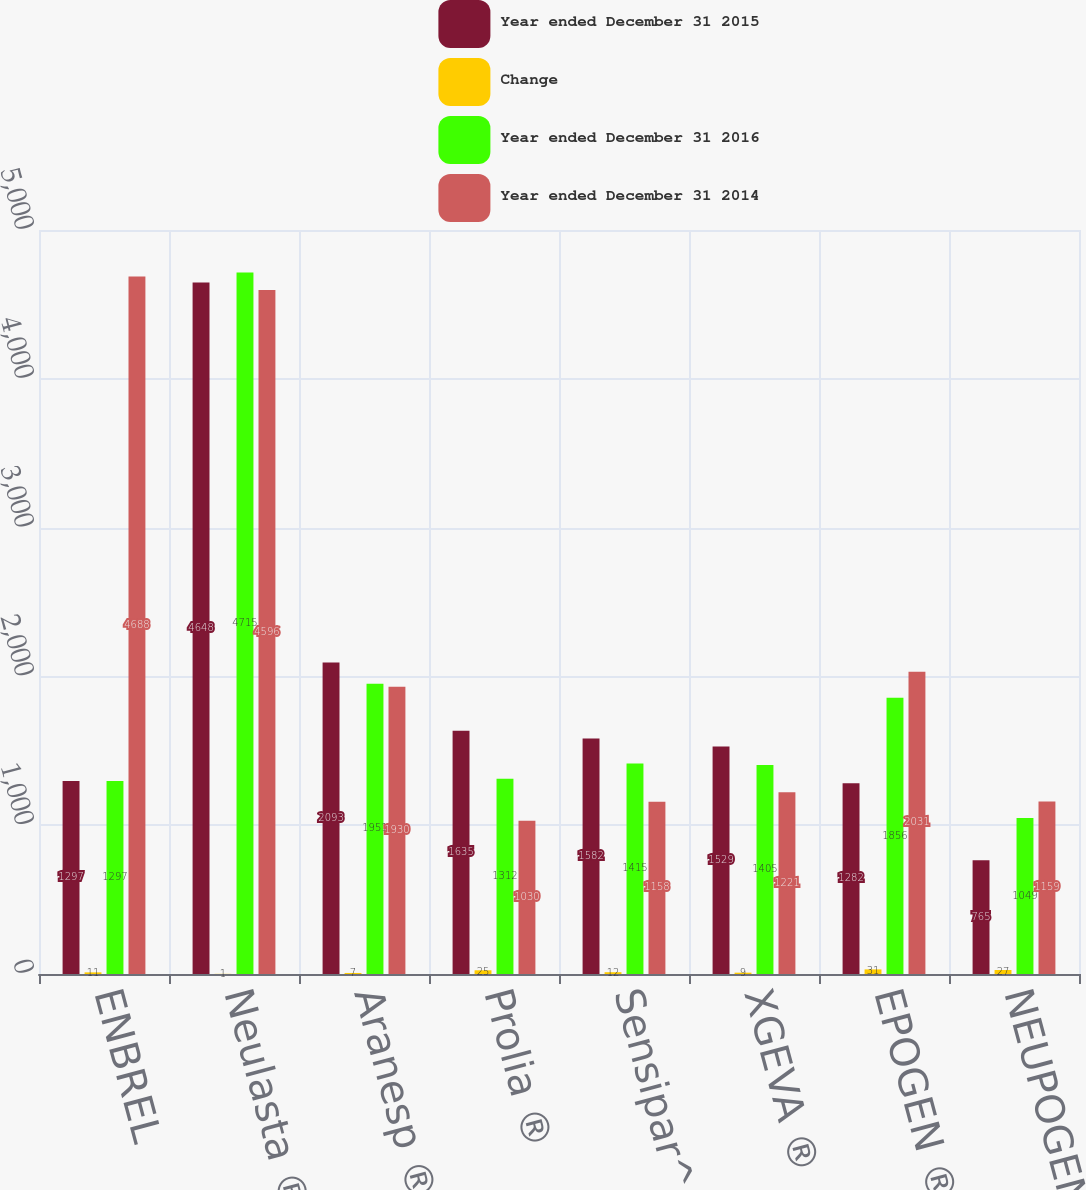<chart> <loc_0><loc_0><loc_500><loc_500><stacked_bar_chart><ecel><fcel>ENBREL<fcel>Neulasta ®<fcel>Aranesp ®<fcel>Prolia ®<fcel>Sensipar^®/Mimpara ®<fcel>XGEVA ®<fcel>EPOGEN ®<fcel>NEUPOGEN ®<nl><fcel>Year ended December 31 2015<fcel>1297<fcel>4648<fcel>2093<fcel>1635<fcel>1582<fcel>1529<fcel>1282<fcel>765<nl><fcel>Change<fcel>11<fcel>1<fcel>7<fcel>25<fcel>12<fcel>9<fcel>31<fcel>27<nl><fcel>Year ended December 31 2016<fcel>1297<fcel>4715<fcel>1951<fcel>1312<fcel>1415<fcel>1405<fcel>1856<fcel>1049<nl><fcel>Year ended December 31 2014<fcel>4688<fcel>4596<fcel>1930<fcel>1030<fcel>1158<fcel>1221<fcel>2031<fcel>1159<nl></chart> 